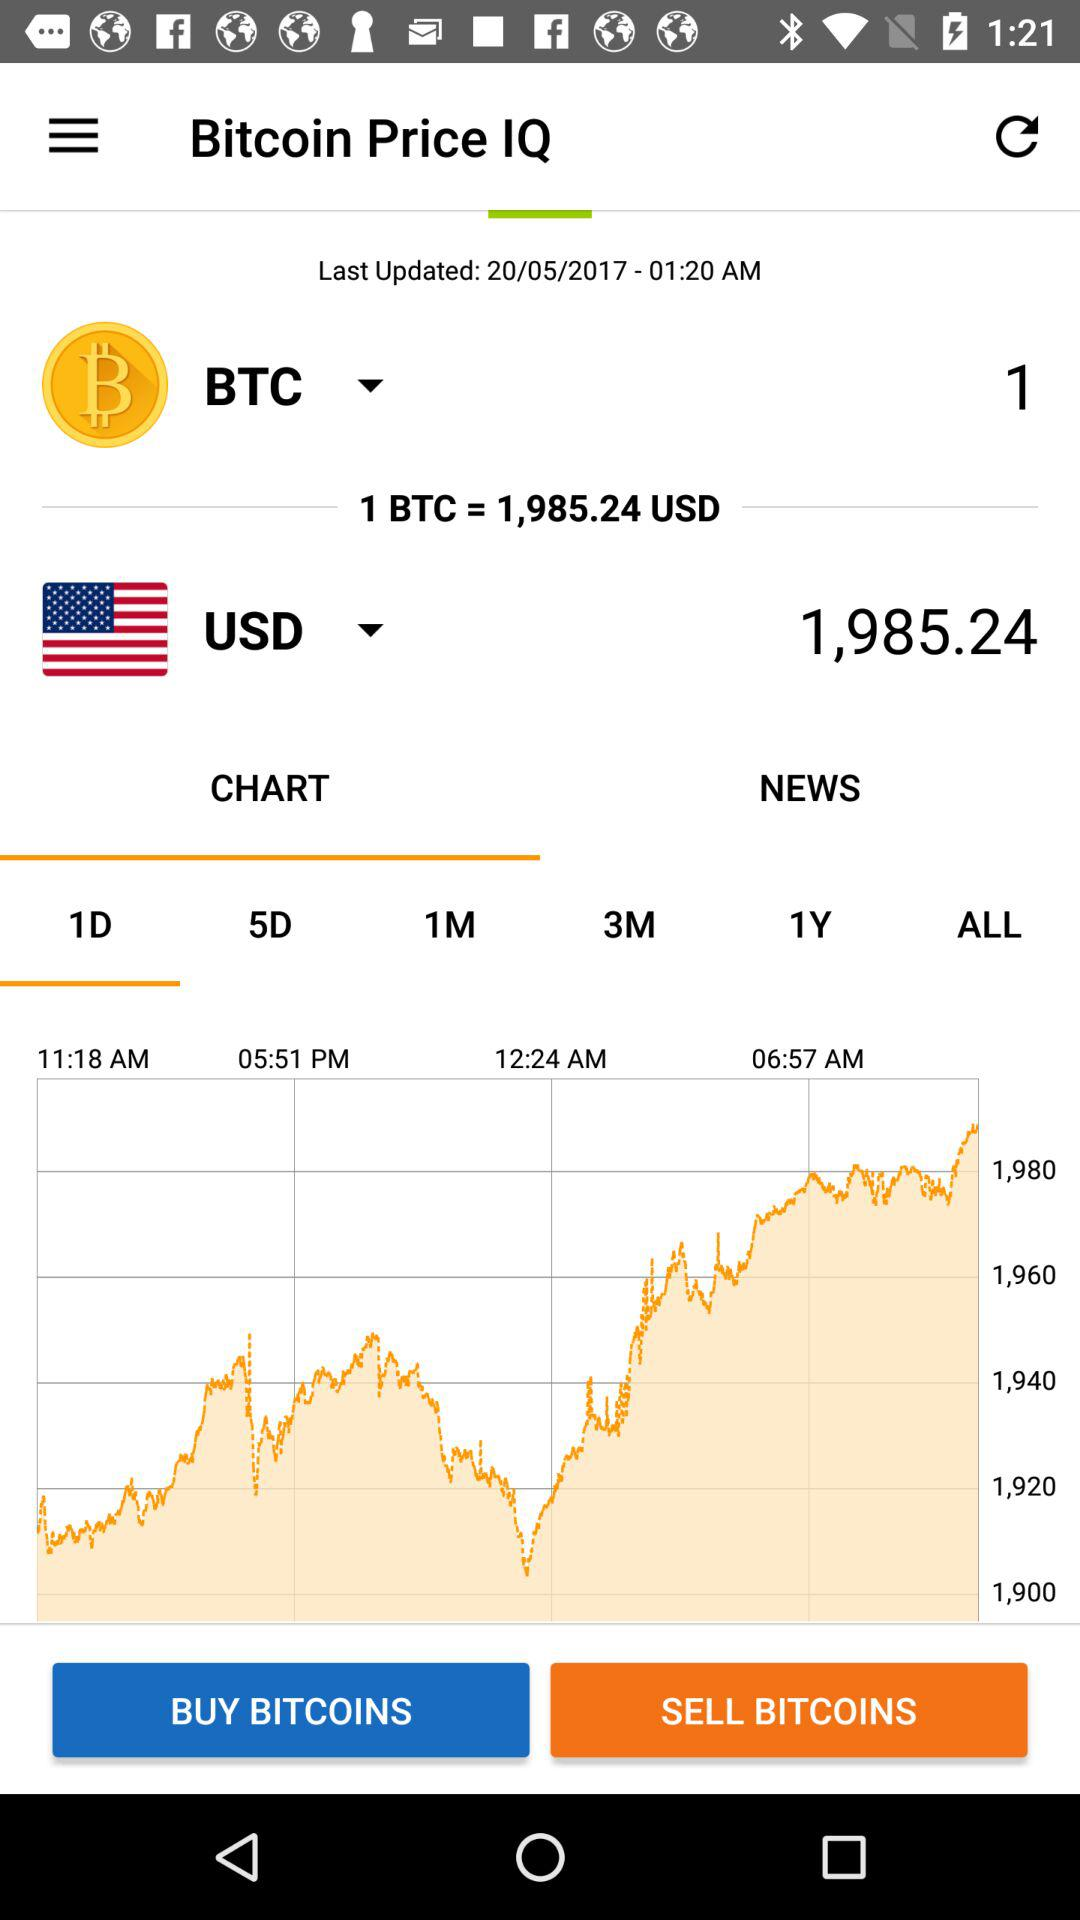What is the value of 1 BTC in USD? The value of 1 BTC is 1,985.24 USD. 